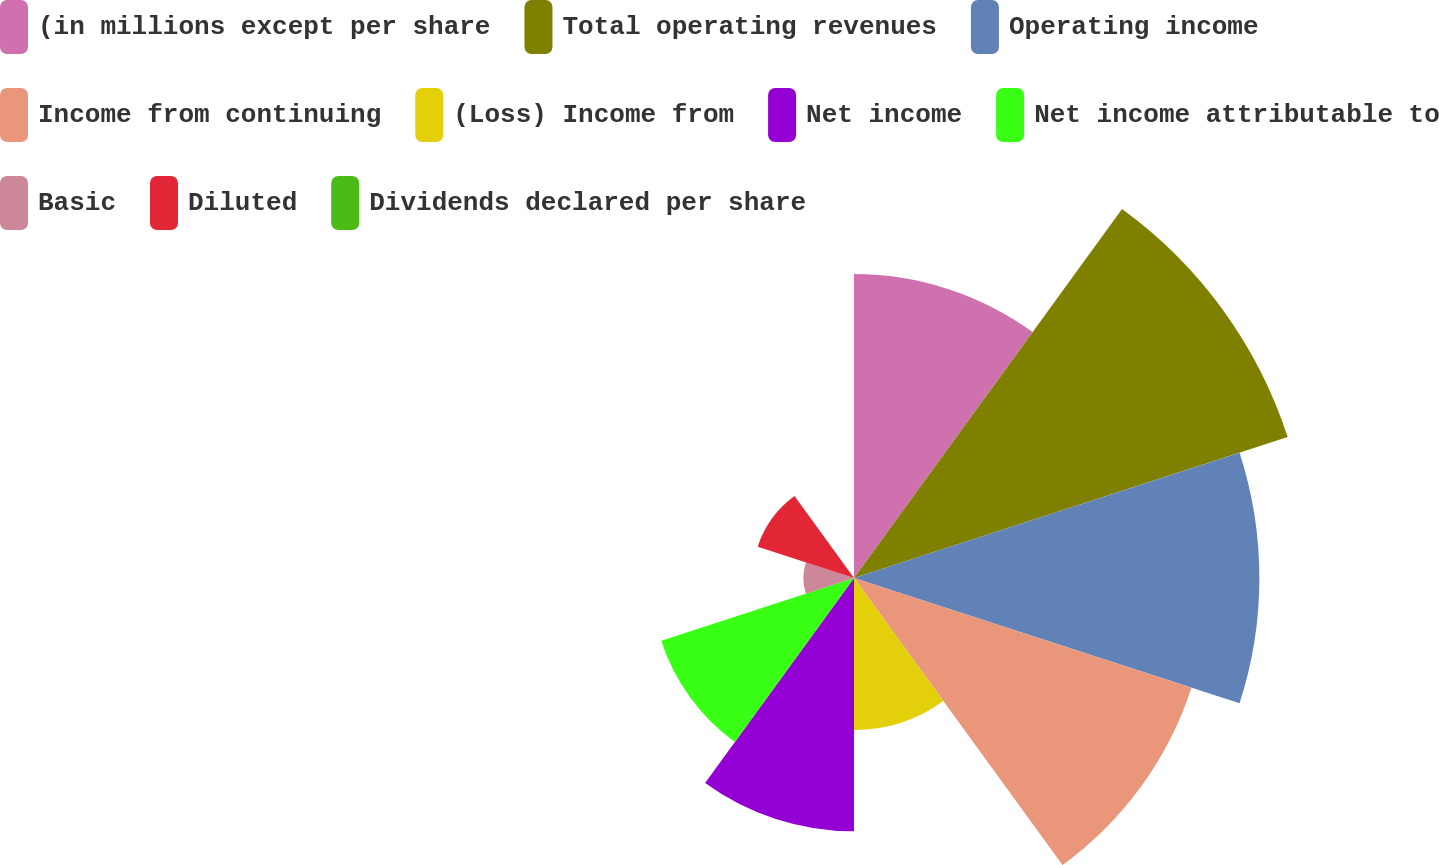Convert chart to OTSL. <chart><loc_0><loc_0><loc_500><loc_500><pie_chart><fcel>(in millions except per share<fcel>Total operating revenues<fcel>Operating income<fcel>Income from continuing<fcel>(Loss) Income from<fcel>Net income<fcel>Net income attributable to<fcel>Basic<fcel>Diluted<fcel>Dividends declared per share<nl><fcel>13.33%<fcel>20.0%<fcel>17.78%<fcel>15.56%<fcel>6.67%<fcel>11.11%<fcel>8.89%<fcel>2.22%<fcel>4.44%<fcel>0.0%<nl></chart> 